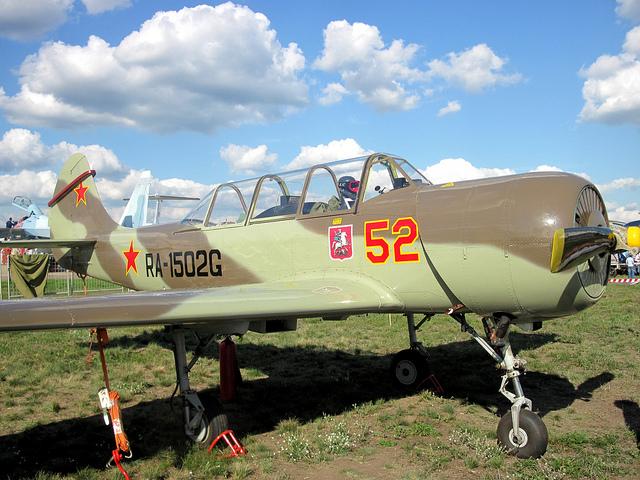What kind of plane is this?
Answer briefly. Antique. What is keeping the plane from moving?
Answer briefly. Chocks. What is the number on the plane?
Be succinct. 52. 